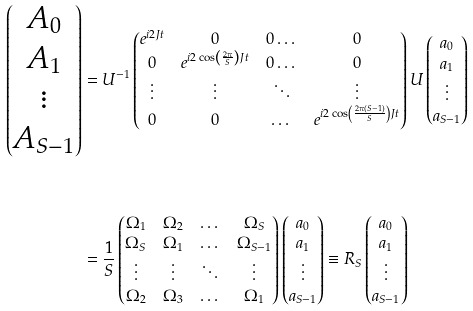Convert formula to latex. <formula><loc_0><loc_0><loc_500><loc_500>\begin{pmatrix} A _ { 0 } \\ A _ { 1 } \\ \vdots \\ A _ { S - 1 } \end{pmatrix} & = U ^ { - 1 } \begin{pmatrix} e ^ { i 2 J t } & 0 & 0 \dots & 0 \\ 0 & e ^ { i 2 \cos \left ( \frac { 2 \pi } { S } \right ) J t } & 0 \dots & 0 \\ \vdots & \vdots & \ddots & \vdots \\ 0 & 0 & \dots & e ^ { i 2 \cos \left ( \frac { 2 \pi ( S - 1 ) } { S } \right ) J t } \end{pmatrix} U \begin{pmatrix} a _ { 0 } \\ a _ { 1 } \\ \vdots \\ a _ { S - 1 } \end{pmatrix} \\ \\ & = \frac { 1 } { S } \begin{pmatrix} \Omega _ { 1 } & \Omega _ { 2 } & \dots & \Omega _ { S } \\ \Omega _ { S } & \Omega _ { 1 } & \dots & \Omega _ { S - 1 } \\ \vdots & \vdots & \ddots & \vdots \\ \Omega _ { 2 } & \Omega _ { 3 } & \dots & \Omega _ { 1 } \end{pmatrix} \begin{pmatrix} a _ { 0 } \\ a _ { 1 } \\ \vdots \\ a _ { S - 1 } \end{pmatrix} \equiv R _ { S } \begin{pmatrix} a _ { 0 } \\ a _ { 1 } \\ \vdots \\ a _ { S - 1 } \end{pmatrix}</formula> 